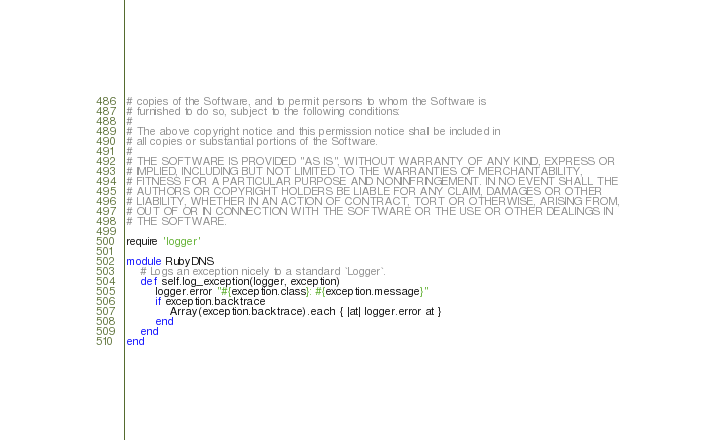<code> <loc_0><loc_0><loc_500><loc_500><_Ruby_># copies of the Software, and to permit persons to whom the Software is
# furnished to do so, subject to the following conditions:
# 
# The above copyright notice and this permission notice shall be included in
# all copies or substantial portions of the Software.
# 
# THE SOFTWARE IS PROVIDED "AS IS", WITHOUT WARRANTY OF ANY KIND, EXPRESS OR
# IMPLIED, INCLUDING BUT NOT LIMITED TO THE WARRANTIES OF MERCHANTABILITY,
# FITNESS FOR A PARTICULAR PURPOSE AND NONINFRINGEMENT. IN NO EVENT SHALL THE
# AUTHORS OR COPYRIGHT HOLDERS BE LIABLE FOR ANY CLAIM, DAMAGES OR OTHER
# LIABILITY, WHETHER IN AN ACTION OF CONTRACT, TORT OR OTHERWISE, ARISING FROM,
# OUT OF OR IN CONNECTION WITH THE SOFTWARE OR THE USE OR OTHER DEALINGS IN
# THE SOFTWARE.

require 'logger'

module RubyDNS
	# Logs an exception nicely to a standard `Logger`.
	def self.log_exception(logger, exception)
		logger.error "#{exception.class}: #{exception.message}"
		if exception.backtrace
			Array(exception.backtrace).each { |at| logger.error at }
		end
	end
end
</code> 